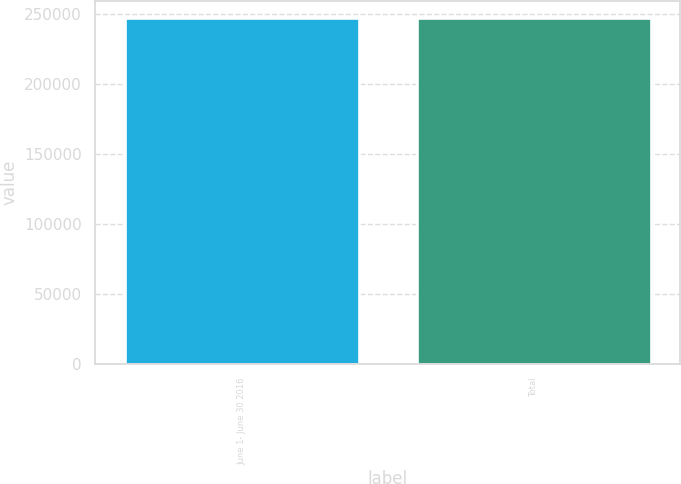<chart> <loc_0><loc_0><loc_500><loc_500><bar_chart><fcel>June 1- June 30 2016<fcel>Total<nl><fcel>246746<fcel>246746<nl></chart> 